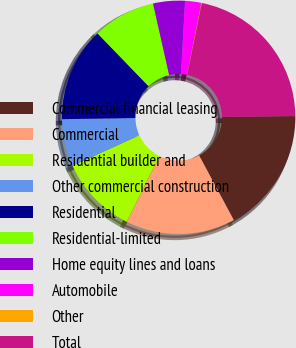<chart> <loc_0><loc_0><loc_500><loc_500><pie_chart><fcel>Commercial financial leasing<fcel>Commercial<fcel>Residential builder and<fcel>Other commercial construction<fcel>Residential<fcel>Residential-limited<fcel>Home equity lines and loans<fcel>Automobile<fcel>Other<fcel>Total<nl><fcel>17.33%<fcel>15.17%<fcel>10.86%<fcel>6.55%<fcel>13.02%<fcel>8.71%<fcel>4.39%<fcel>2.24%<fcel>0.08%<fcel>21.64%<nl></chart> 